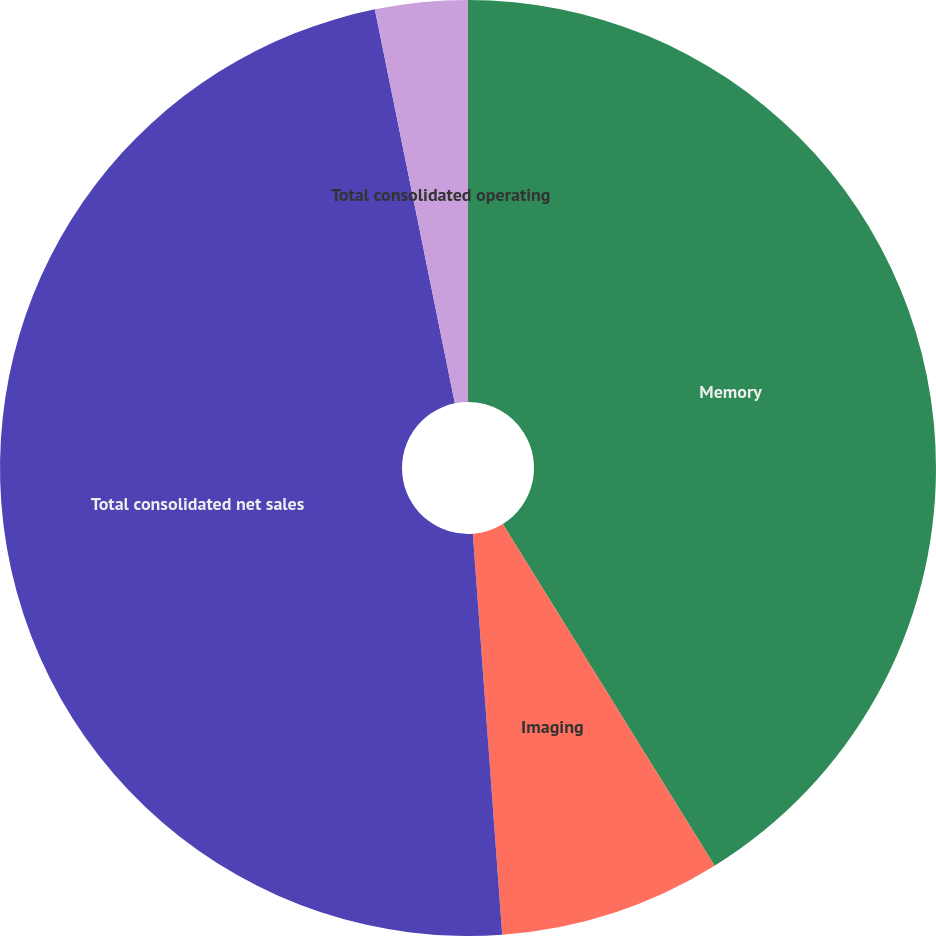Convert chart to OTSL. <chart><loc_0><loc_0><loc_500><loc_500><pie_chart><fcel>Memory<fcel>Imaging<fcel>Total consolidated net sales<fcel>Total consolidated operating<nl><fcel>41.17%<fcel>7.67%<fcel>47.98%<fcel>3.19%<nl></chart> 